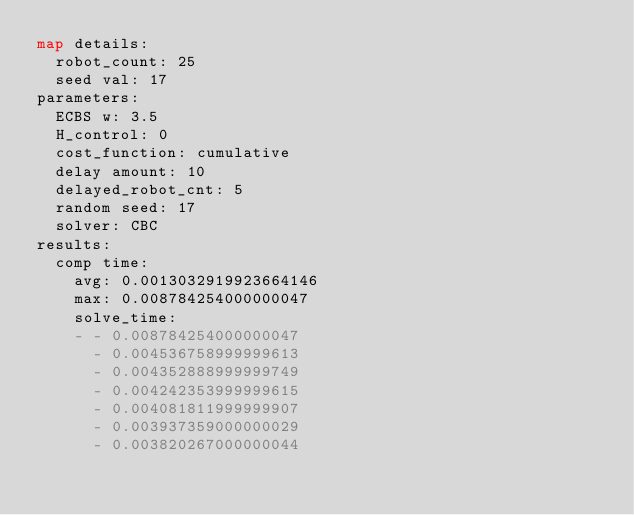Convert code to text. <code><loc_0><loc_0><loc_500><loc_500><_YAML_>map details:
  robot_count: 25
  seed val: 17
parameters:
  ECBS w: 3.5
  H_control: 0
  cost_function: cumulative
  delay amount: 10
  delayed_robot_cnt: 5
  random seed: 17
  solver: CBC
results:
  comp time:
    avg: 0.0013032919923664146
    max: 0.008784254000000047
    solve_time:
    - - 0.008784254000000047
      - 0.004536758999999613
      - 0.004352888999999749
      - 0.004242353999999615
      - 0.004081811999999907
      - 0.003937359000000029
      - 0.003820267000000044</code> 